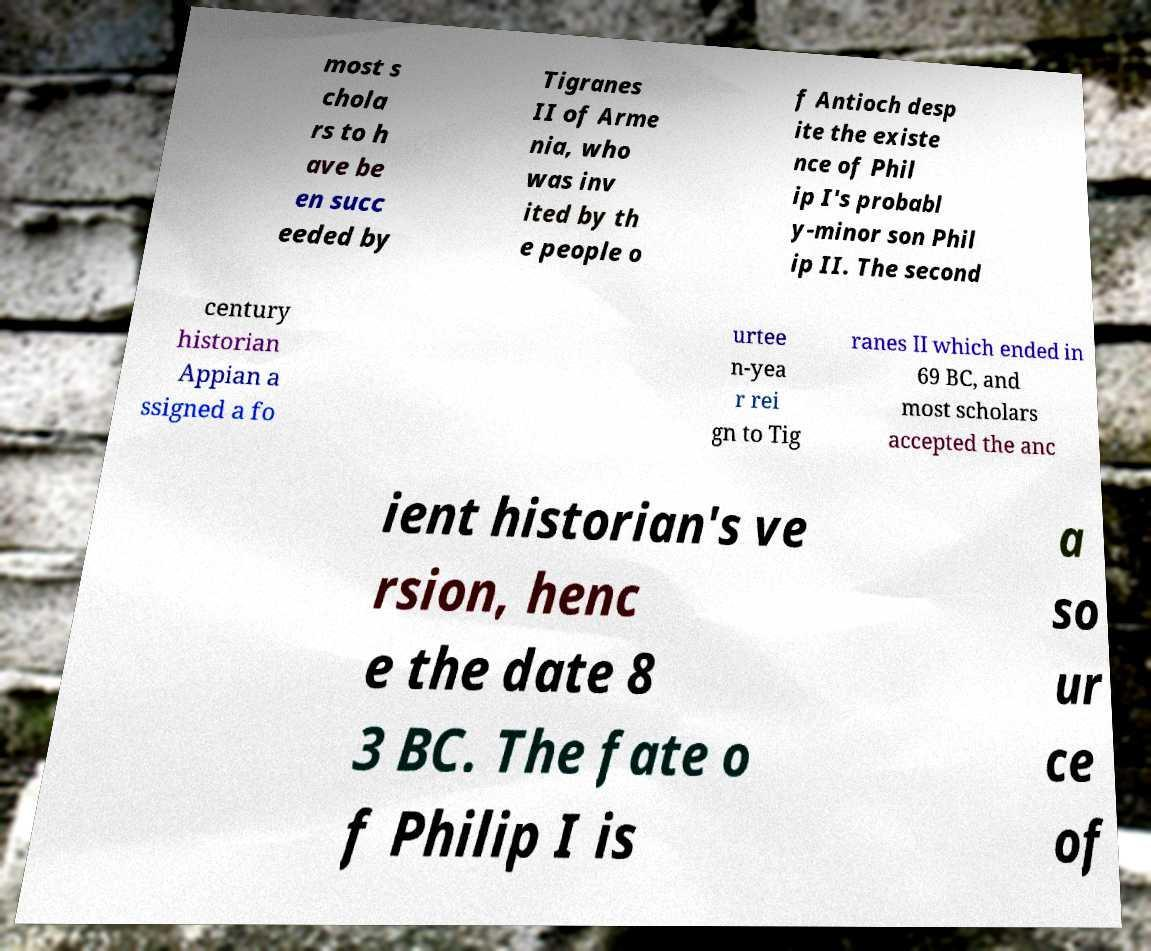Please read and relay the text visible in this image. What does it say? most s chola rs to h ave be en succ eeded by Tigranes II of Arme nia, who was inv ited by th e people o f Antioch desp ite the existe nce of Phil ip I's probabl y-minor son Phil ip II. The second century historian Appian a ssigned a fo urtee n-yea r rei gn to Tig ranes II which ended in 69 BC, and most scholars accepted the anc ient historian's ve rsion, henc e the date 8 3 BC. The fate o f Philip I is a so ur ce of 